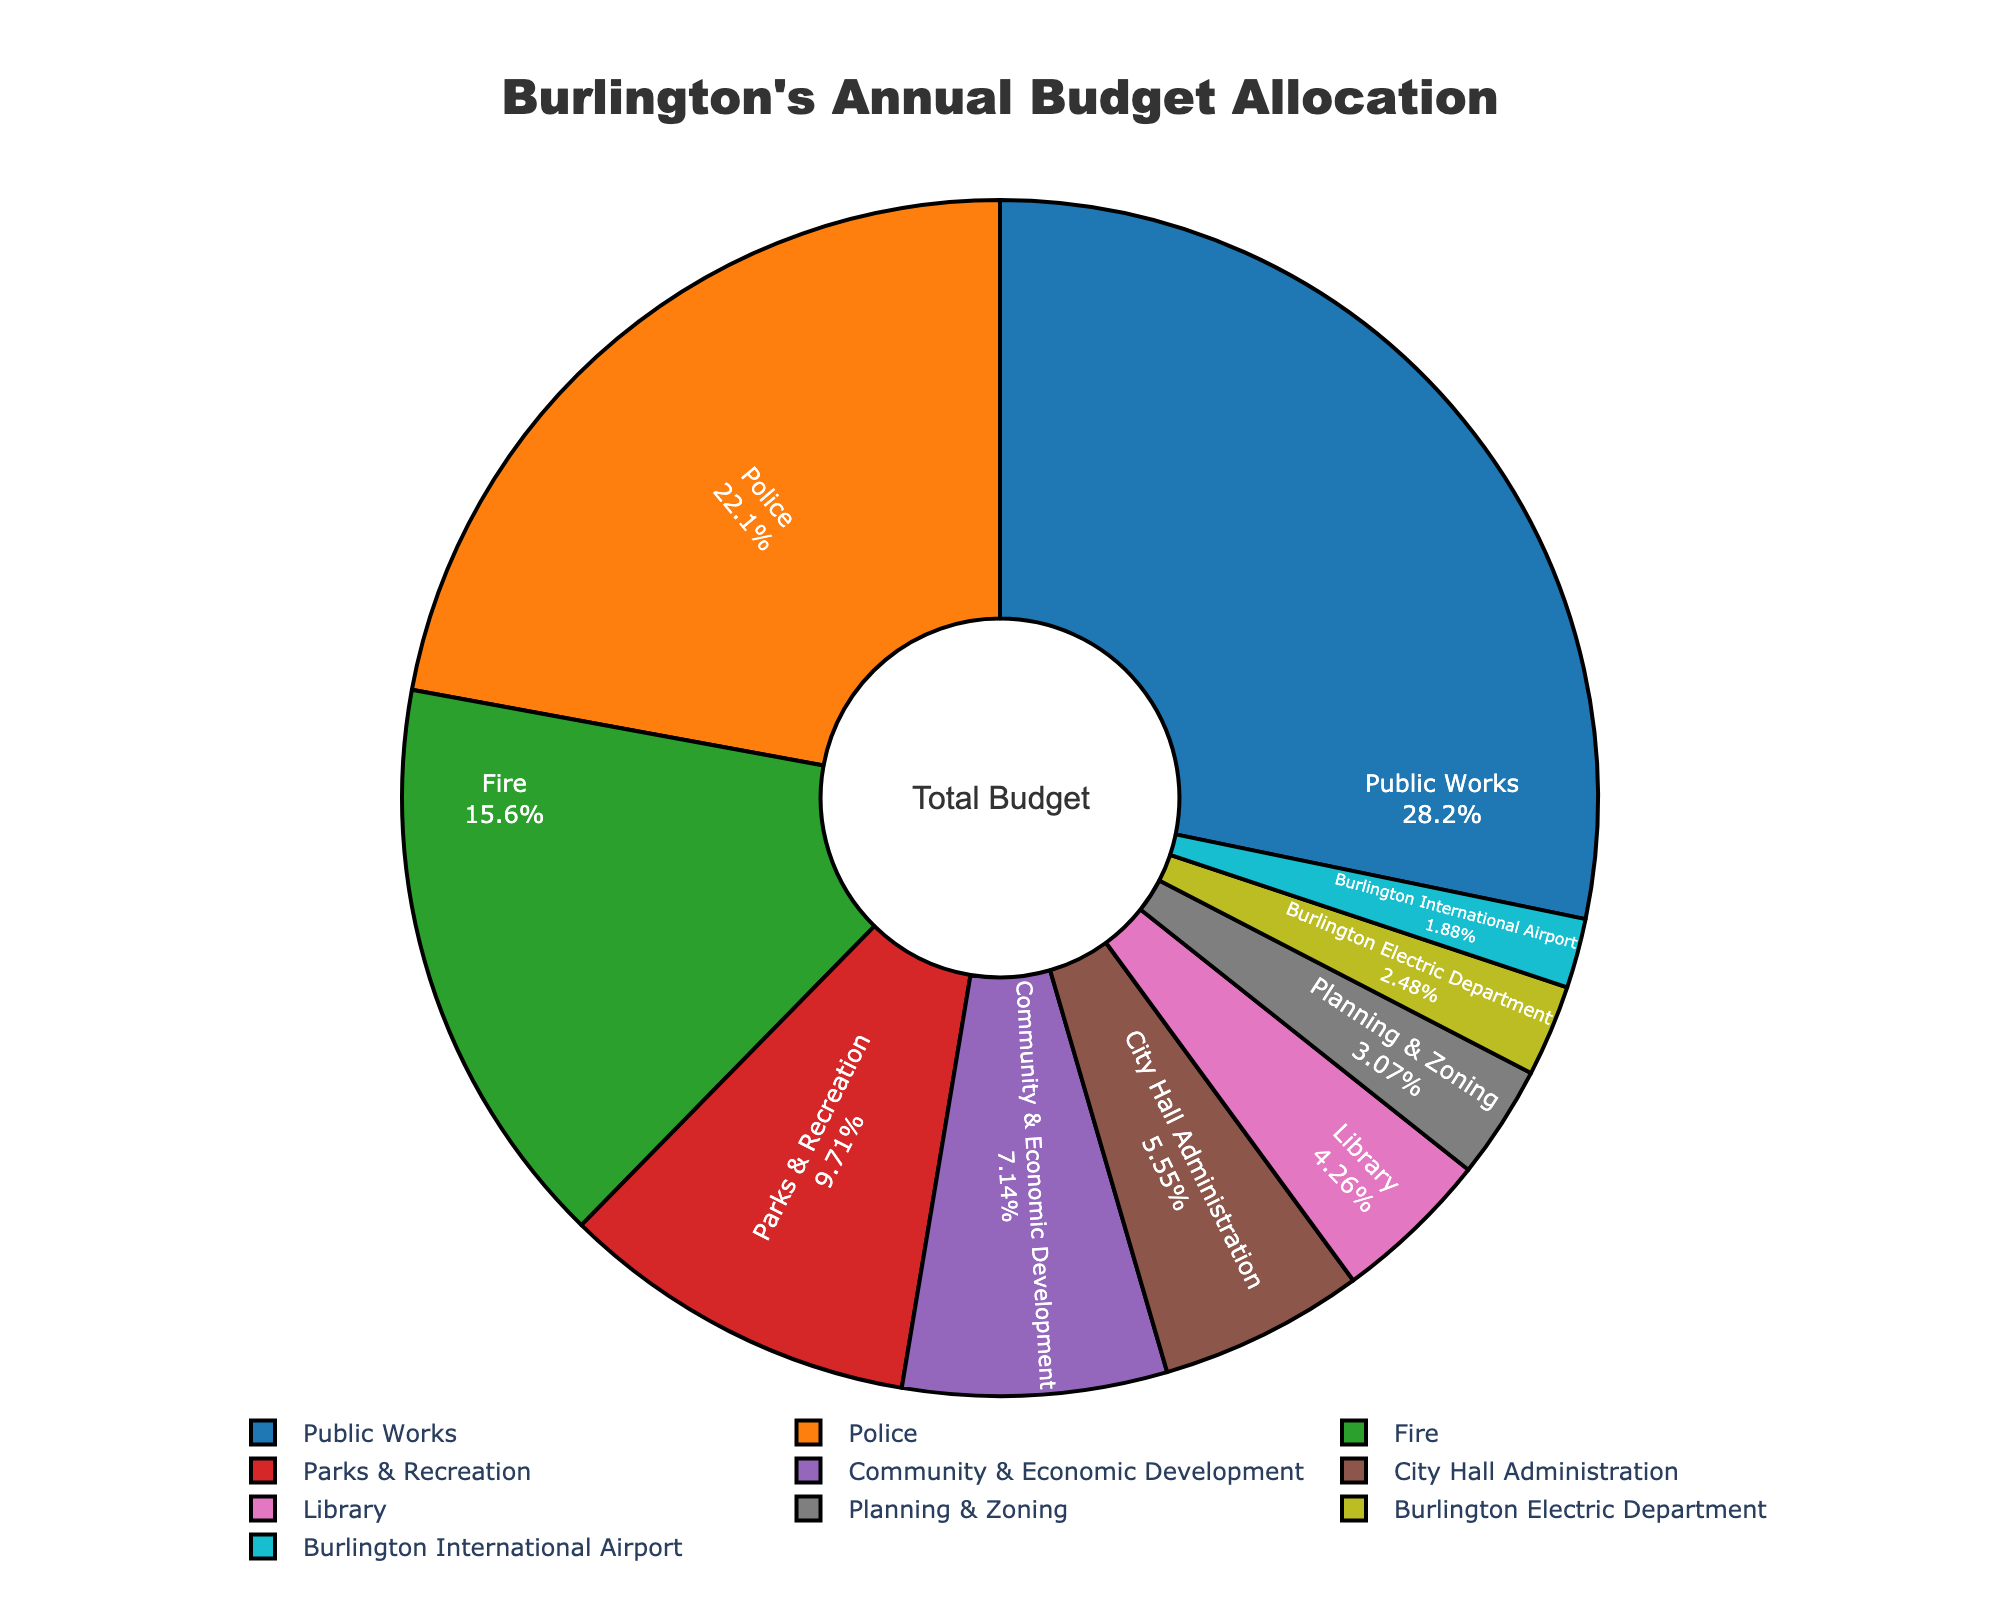What percentage of the budget is allocated to Public Works? Look at the slice labeled "Public Works" in the pie chart, which also shows the percentage.
Answer: 28.5% What's the combined budget allocation of Police and Fire departments? Read the percentage allocations for Police and Fire, which are 22.3% and 15.7%, respectively. Add them together: 22.3% + 15.7% = 38.0%.
Answer: 38.0% Which department receives more funding: Burlington International Airport or Library? Compare the slices for Burlington International Airport and Library. Burlington International Airport is 1.9%, and Library is 4.3%. The Library receives more funding.
Answer: Library What is the total budget allocation for departments other than Public Works and Police? Sum the percentages of all departments except Public Works and Police. (15.7 + 9.8 + 7.2 + 5.6 + 4.3 + 3.1 + 2.5 + 1.9) = 50.1%.
Answer: 50.1% How does the budget allocation for Parks & Recreation compare to Planning & Zoning? Look at the slices for Parks & Recreation (9.8%) and Planning & Zoning (3.1%), Parks & Recreation is greater.
Answer: Parks & Recreation Which department's budget allocation is closest to 10%? The closest value to 10% based on the pie slices is for Parks & Recreation, which is 9.8%.
Answer: Parks & Recreation What percentage of the budget is allocated to both City Hall Administration and Burlington Electric Department combined? Add the percentages for City Hall Administration (5.6%) and Burlington Electric Department (2.5%): 5.6% + 2.5% = 8.1%.
Answer: 8.1% Is the Community & Economic Development budget allocation higher than the City Hall Administration's? Compare the percentages: Community & Economic Development is 7.2% and City Hall Administration is 5.6%, so yes, it is higher.
Answer: Yes How does the funding for Parks & Recreation compare to the funding for Fire? Check the percentages: Parks & Recreation (9.8%) vs. Fire (15.7%), Fire has higher funding.
Answer: Fire Which department has the largest slice in the pie chart? The largest slice in the pie chart corresponds to Public Works, which is 28.5%.
Answer: Public Works 